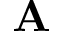<formula> <loc_0><loc_0><loc_500><loc_500>A</formula> 